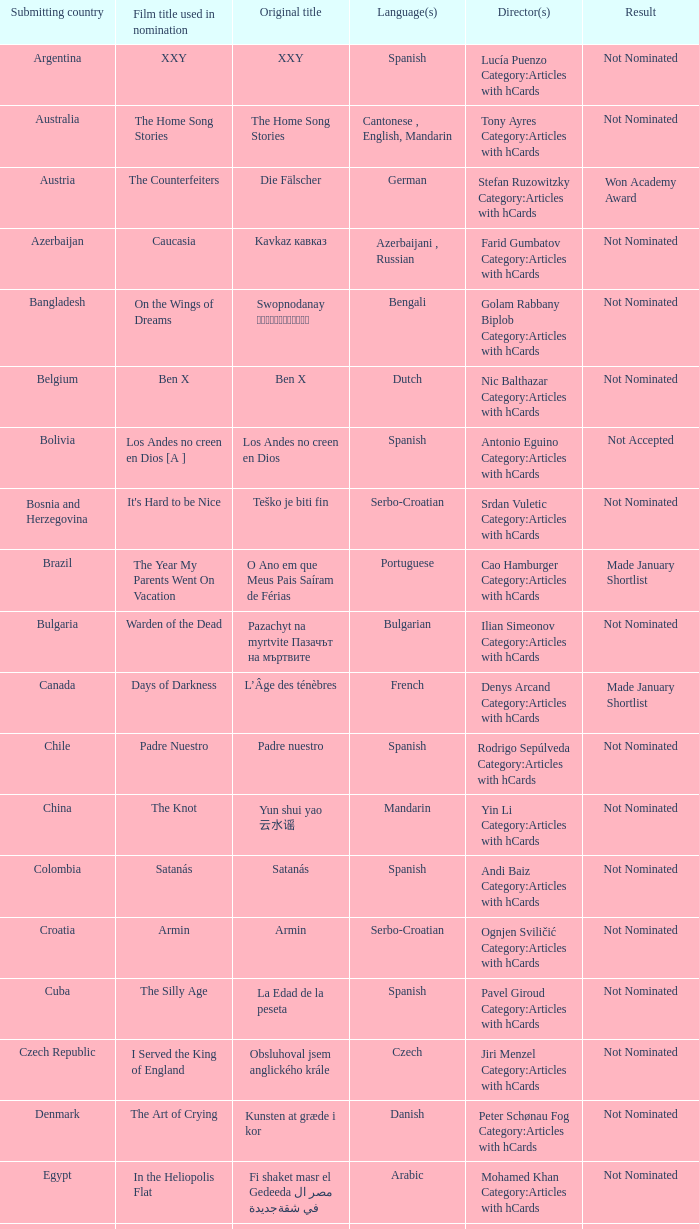What was the lebanese movie's title? Caramel. 